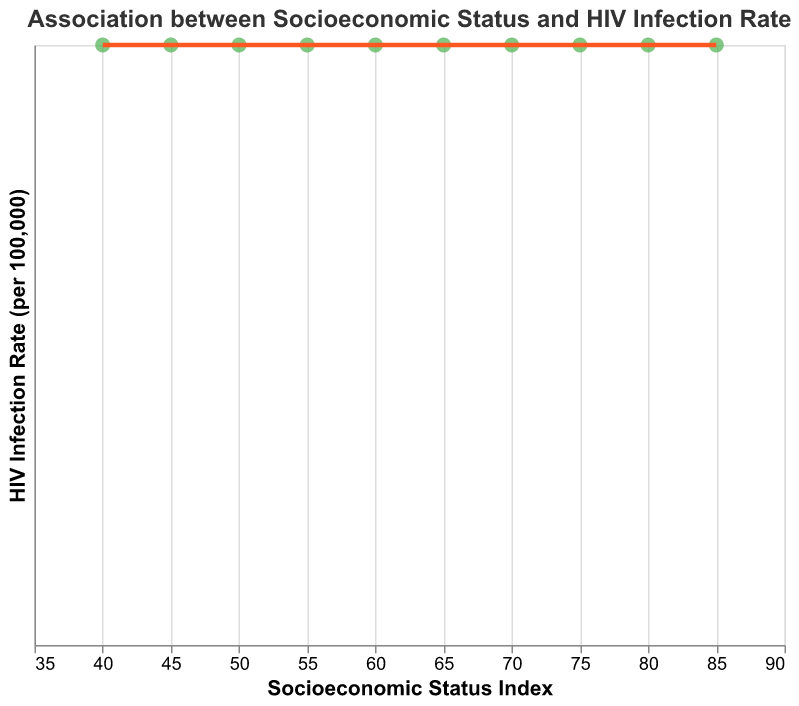What is the title of the scatter plot? The title is located at the top of the scatter plot and can be directly read. It indicates the overall focus of the figure, which is the relationship being investigated.
Answer: Association between Socioeconomic Status and HIV Infection Rate How many data points are displayed in the scatter plot? The number of data points corresponds to the number of regions listed in the provided dataset. Each point represents a region.
Answer: 10 What are the axes labels in the scatter plot? The labels for the x-axis and y-axis are indicated along the respective axes and describe the quantities being measured.
Answer: Socioeconomic Status Index (x-axis) and HIV Infection Rate (per 100,000) (y-axis) Which region has the highest HIV infection rate and what is its socioeconomic status index? By identifying the highest point on the y-axis (HIV Infection Rate), you can find the corresponding region and associated socioeconomic status index from the plot's tooltip or data.
Answer: Sub-Saharan Africa, 40 What trend is observed between socioeconomic status and HIV infection rates according to the trend line? The trend line visually indicates the overall direction or relationship between socioeconomic status and HIV infection rates, typically either upward or downward.
Answer: Negative correlation What is the approximate HIV infection rate in the region with a socioeconomic status index of 65? Identify the data point associated with a socioeconomic status of 65 on the x-axis, and read the corresponding value on the y-axis or tooltip for the HIV infection rate.
Answer: 50 How many regions have a socioeconomic status index greater than 70? Count the number of data points (regions) that are located to the right of the 70 mark on the x-axis.
Answer: 3 Compare the HIV infection rates between East Asia and Eastern Europe. Which region has a higher rate? Locate the data points for East Asia and Eastern Europe and compare their y-axis values (HIV Infection Rate).
Answer: Eastern Europe What is the range of socioeconomic status index values displayed in the scatter plot? Identify the minimum and maximum x-axis values (socioeconomic status indices) from the data points and subtract the minimum from the maximum.
Answer: 40 to 85 Which region has the lowest HIV infection rate and what is its socioeconomic status index? By identifying the lowest point on the y-axis (HIV Infection Rate), you can find the corresponding region and associated socioeconomic status index from the plot's tooltip or data.
Answer: Western Europe, 85 